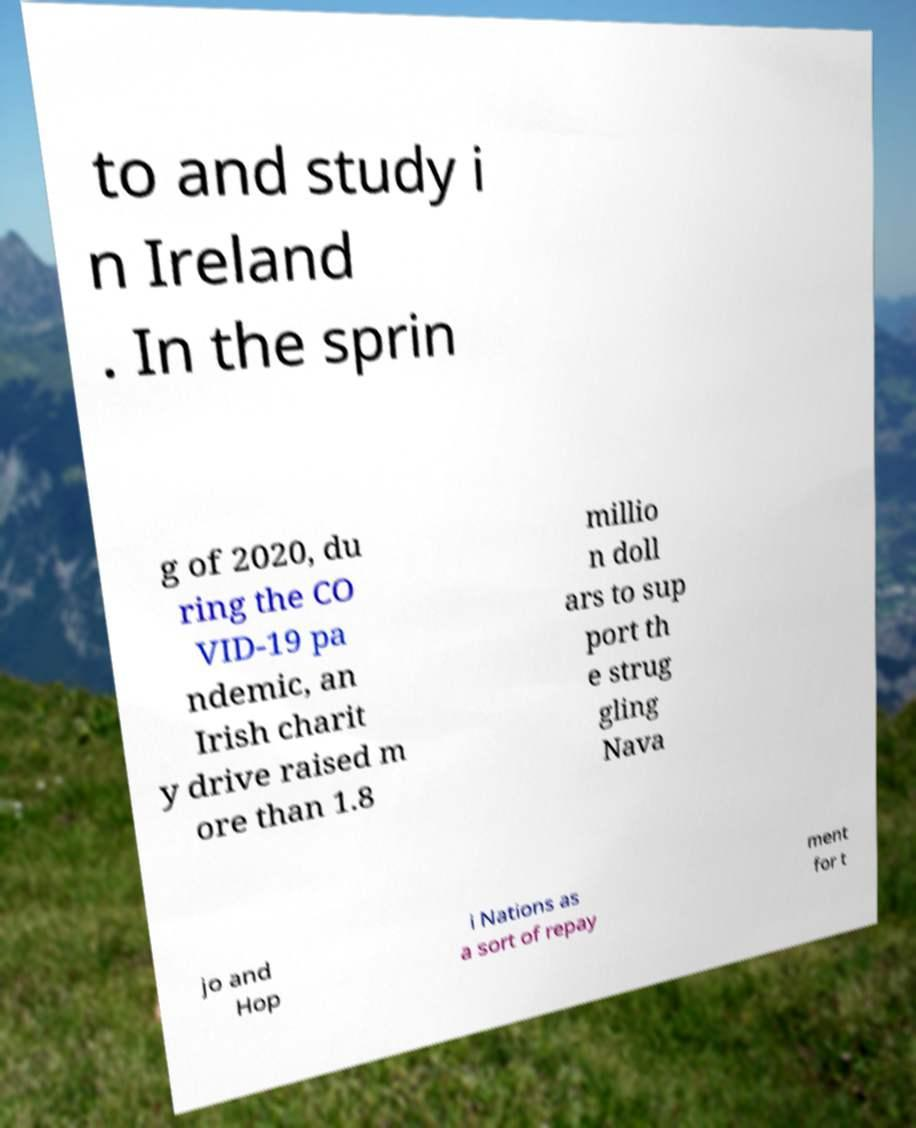I need the written content from this picture converted into text. Can you do that? to and study i n Ireland . In the sprin g of 2020, du ring the CO VID-19 pa ndemic, an Irish charit y drive raised m ore than 1.8 millio n doll ars to sup port th e strug gling Nava jo and Hop i Nations as a sort of repay ment for t 